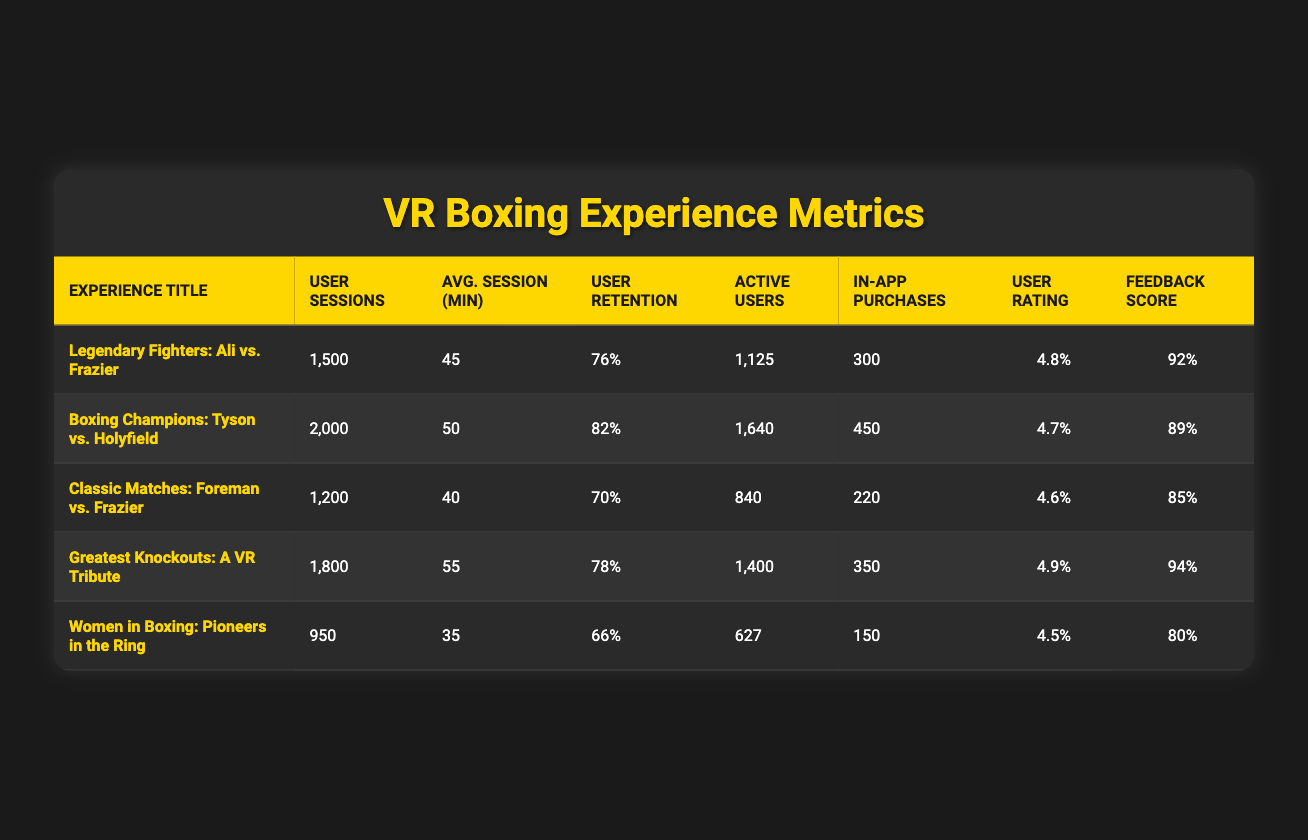What is the User Rating for the experience "Greatest Knockouts: A VR Tribute"? The table directly lists the User Rating for each experience. For "Greatest Knockouts: A VR Tribute", it clearly shows the User Rating as 4.9.
Answer: 4.9 How many User Sessions were recorded for "Women in Boxing: Pioneers in the Ring"? The User Sessions for "Women in Boxing: Pioneers in the Ring" can be found directly under its respective row, which states there were 950 User Sessions.
Answer: 950 Which boxing experience has the highest User Retention Rate? Comparing the User Retention Rates listed in the table, "Boxing Champions: Tyson vs. Holyfield" has the highest rate at 82%, while other experiences have lower rates.
Answer: Boxing Champions: Tyson vs. Holyfield What is the total number of Active Users across all boxing experiences? To find the total Active Users, sum the Active Users across all experiences: 1125 + 1640 + 840 + 1400 + 627 = 4832. The total number of Active Users is 4832.
Answer: 4832 Is the User Rating for "Legendary Fighters: Ali vs. Frazier" higher than that of "Women in Boxing: Pioneers in the Ring"? The table shows that "Legendary Fighters: Ali vs. Frazier" has a User Rating of 4.8 while "Women in Boxing: Pioneers in the Ring" has a User Rating of 4.5. Since 4.8 is greater than 4.5, the statement is true.
Answer: Yes What is the average session duration for "Classic Matches: Foreman vs. Frazier"? The Average Session Duration is indicated directly in the table. For "Classic Matches: Foreman vs. Frazier", it shows an Average Session Duration of 40 minutes.
Answer: 40 minutes How many In-App Purchases did all experiences combined generate? To find the total In-App Purchases, add the In-App Purchases across all experiences: 300 + 450 + 220 + 350 + 150 = 1470. The total number of In-App Purchases is 1470.
Answer: 1470 Is there a boxing experience that has a User Retention Rate below 70%? Checking the User Retention Rates in the table, "Women in Boxing: Pioneers in the Ring" has a Retention Rate of 66%, which is below 70%. Hence, the claim is true.
Answer: Yes What is the average User Rating of all boxing experiences? To find the average User Rating, sum the ratings (4.8 + 4.7 + 4.6 + 4.9 + 4.5 = 24.5) and then divide by the number of experiences (5). Average = 24.5 / 5 = 4.9.
Answer: 4.9 